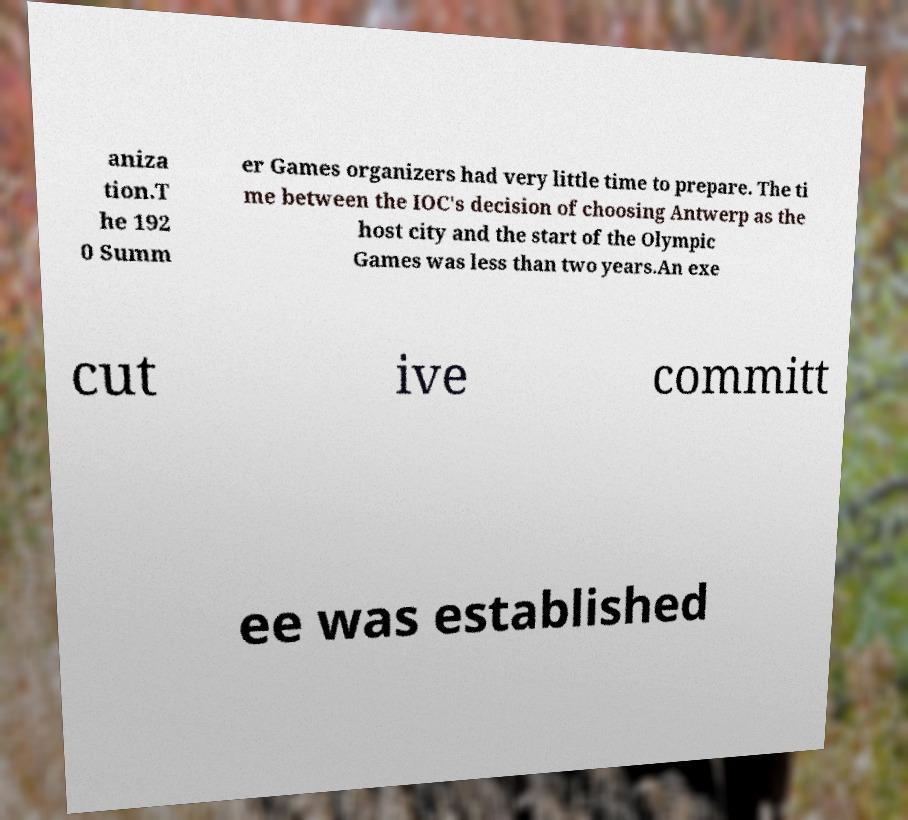For documentation purposes, I need the text within this image transcribed. Could you provide that? aniza tion.T he 192 0 Summ er Games organizers had very little time to prepare. The ti me between the IOC's decision of choosing Antwerp as the host city and the start of the Olympic Games was less than two years.An exe cut ive committ ee was established 